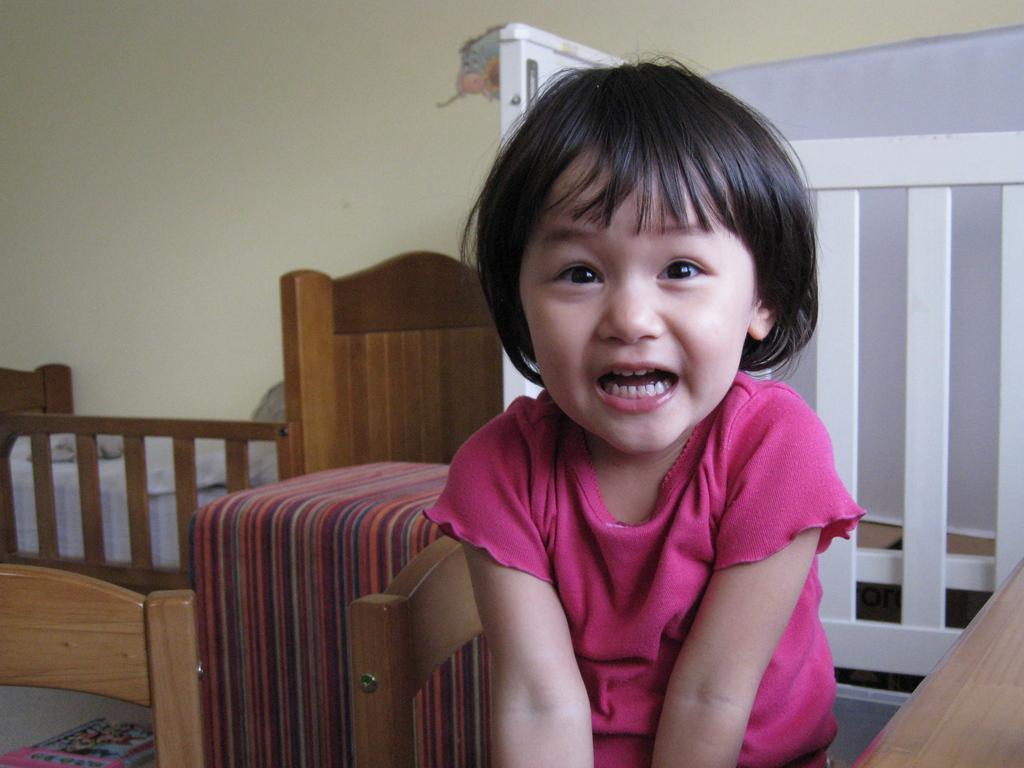Who is present in the image? There is a girl in the image. What is the girl wearing? The girl is wearing a pink dress. What is the girl's expression in the image? The girl is smiling. What type of furniture can be seen in the image? There is a bed and a cot in the image. What is the color of the fencing in the image? The fencing in the image is white. What is visible in the background of the image? There is a wall in the background of the image. What type of paste is the girl using to join the snake in the image? There is no paste, joining, or snake present in the image. 